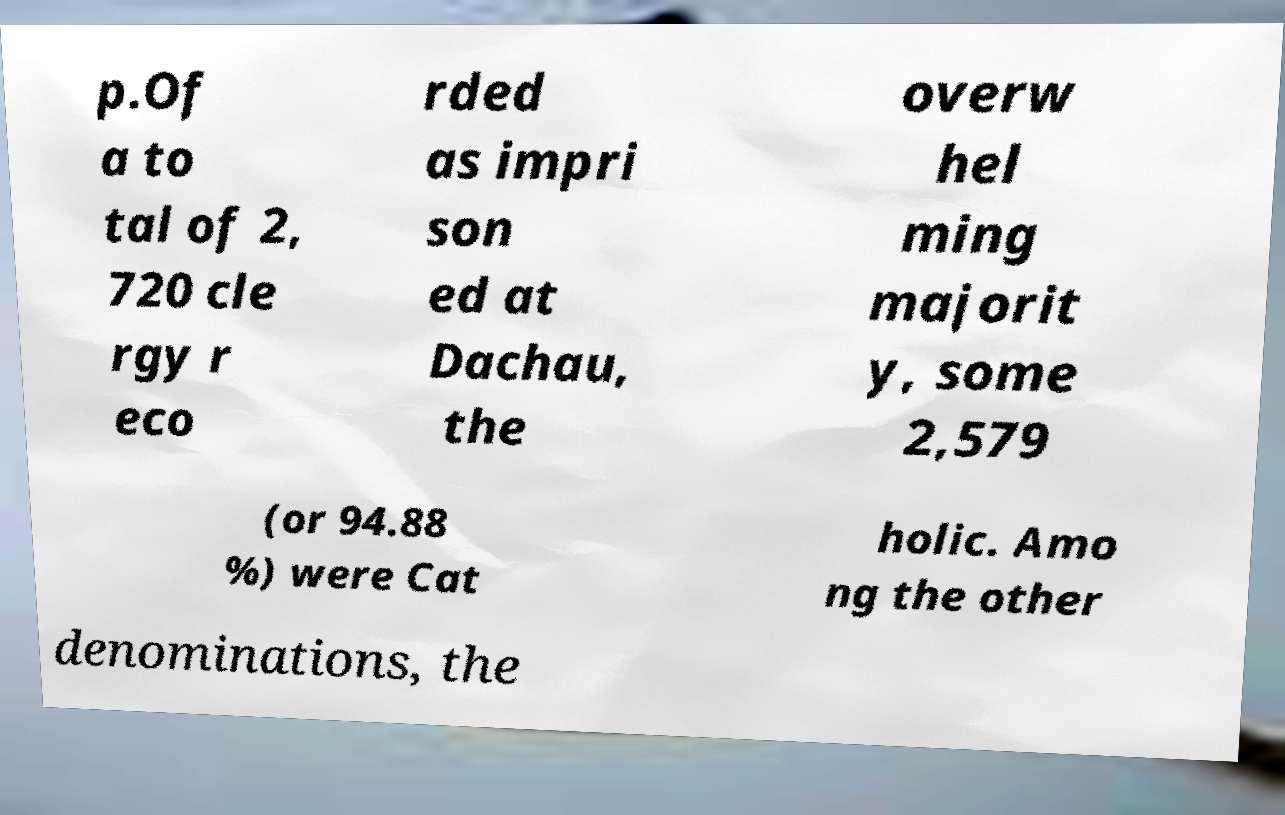For documentation purposes, I need the text within this image transcribed. Could you provide that? p.Of a to tal of 2, 720 cle rgy r eco rded as impri son ed at Dachau, the overw hel ming majorit y, some 2,579 (or 94.88 %) were Cat holic. Amo ng the other denominations, the 